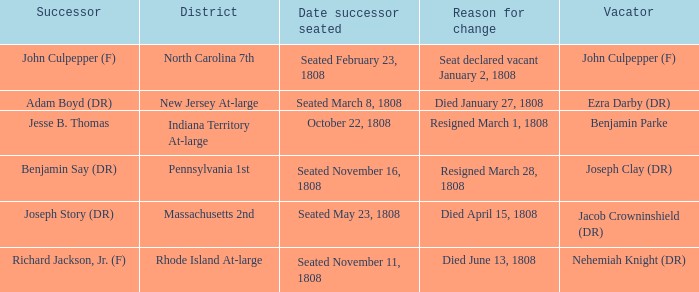What is the date successor seated where Massachusetts 2nd is the district? Seated May 23, 1808. 